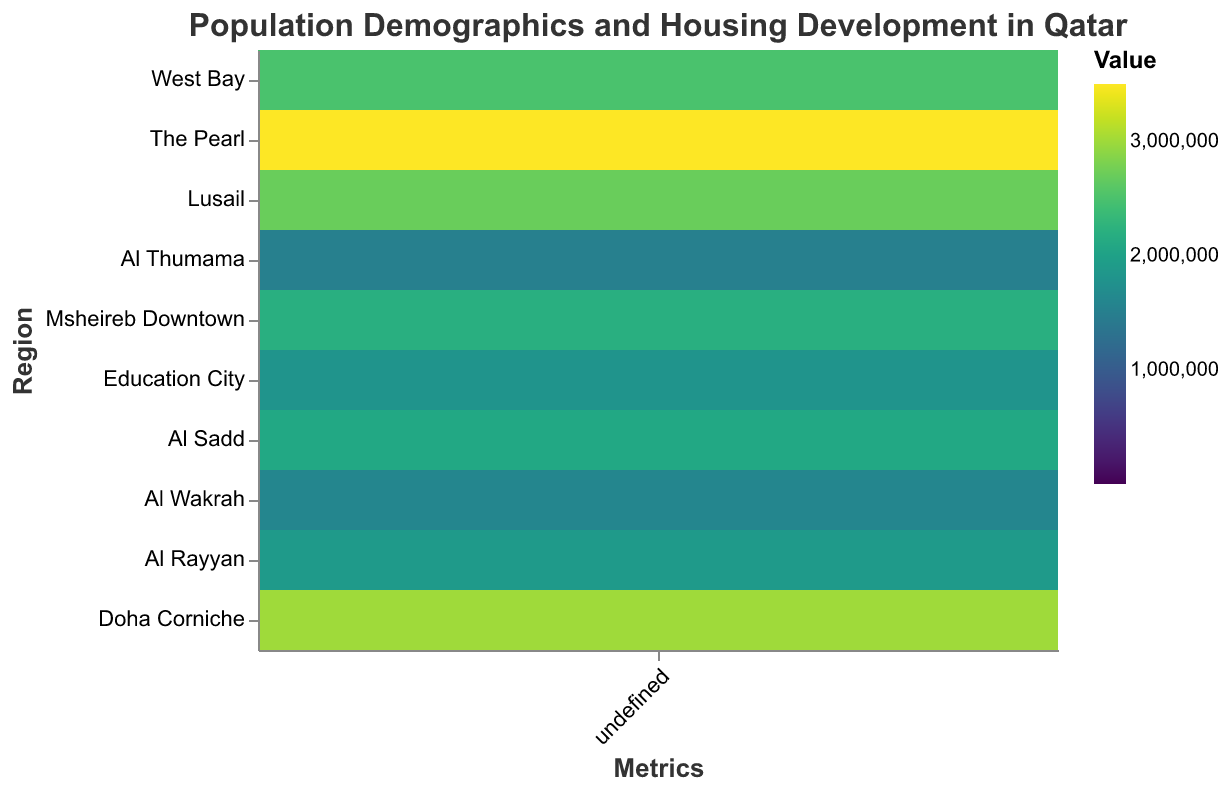What is the title of the figure? The title can be seen at the top of the figure.
Answer: Population Demographics and Housing Development in Qatar Which region has the highest population density? By looking at the heatmap, find the region with the darkest color corresponding to Population Density.
Answer: West Bay How many regions have an average household size greater than 3.5? Check the color shades for the Average Household Size and count the number of regions where the shade indicates a value greater than 3.5.
Answer: 4 regions Which metric has the highest value in The Pearl? Compare the color intensities for each metric in The Pearl and identify the darkest shade.
Answer: Average Property Value (QAR) What is the difference in the number of new housing units between Lusail and Al Wakrah? Subtract the number of new housing units in Al Wakrah from those in Lusail: 300 - 250.
Answer: 50 units Which region has the lowest value of average property value? Find the region with the lightest color shade corresponding to Average Property Value (QAR).
Answer: Al Thumama Compare the population density of Msheireb Downtown and Al Sadd. Which is higher? Look at the color intensities for Population Density in both regions and determine which is darker.
Answer: Al Sadd How does the property value in Education City compare to Al Rayyan? Compare the color shades for Average Property Value (QAR) in both regions to see which is darker: Education City or Al Rayyan.
Answer: Education City is higher What is the average number of new housing units in regions with a population density greater than 8000? Identify regions with population density greater than 8000, add their new housing units (150+200+80), then divide by the number of regions (3).
Answer: 143.33 units Are there any regions where the average household size and number of new housing units are both greater than average? First, find the average values for the entire dataset: Average Household Size ~3.55, Number of New Housing Units ~169. Then check each region if both metrics are greater than these averages.
Answer: Lusail and Al Wakrah 